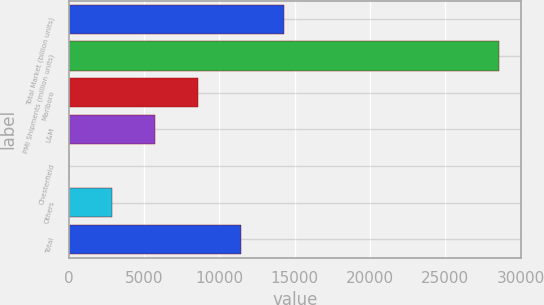Convert chart to OTSL. <chart><loc_0><loc_0><loc_500><loc_500><bar_chart><fcel>Total Market (billion units)<fcel>PMI Shipments (million units)<fcel>Marlboro<fcel>L&M<fcel>Chesterfield<fcel>Others<fcel>Total<nl><fcel>14288.2<fcel>28575<fcel>8573.55<fcel>5716.2<fcel>1.5<fcel>2858.85<fcel>11430.9<nl></chart> 